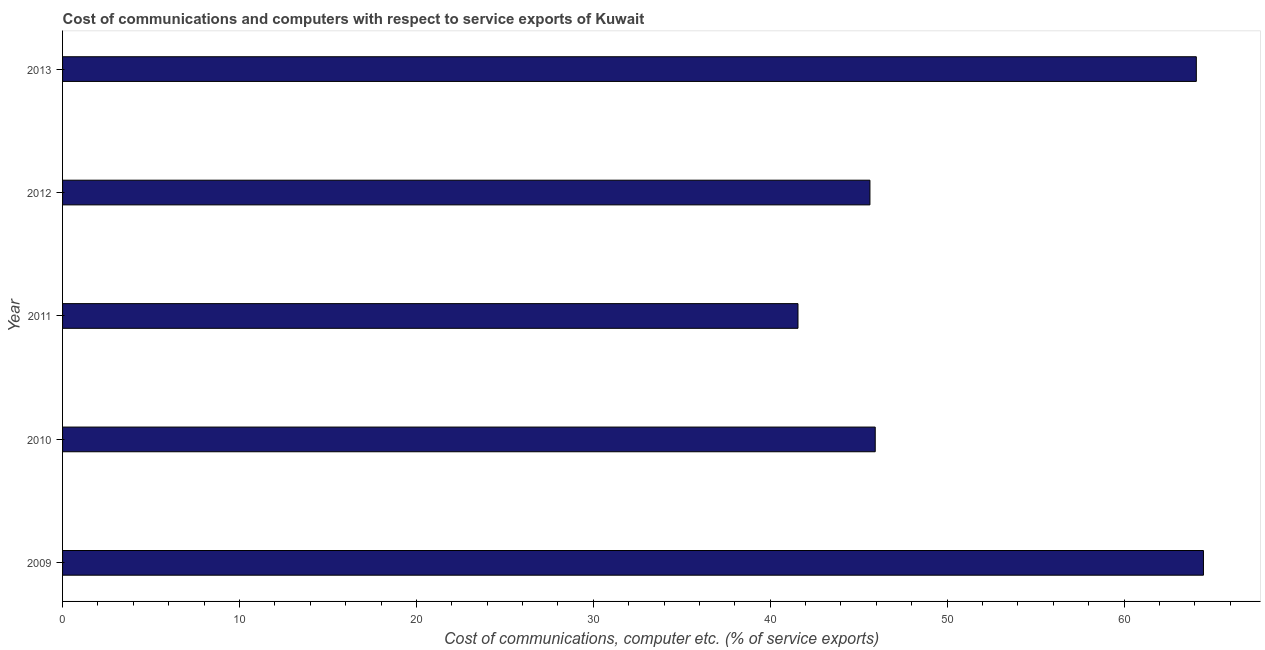What is the title of the graph?
Your answer should be very brief. Cost of communications and computers with respect to service exports of Kuwait. What is the label or title of the X-axis?
Make the answer very short. Cost of communications, computer etc. (% of service exports). What is the label or title of the Y-axis?
Make the answer very short. Year. What is the cost of communications and computer in 2013?
Make the answer very short. 64.09. Across all years, what is the maximum cost of communications and computer?
Keep it short and to the point. 64.49. Across all years, what is the minimum cost of communications and computer?
Offer a terse response. 41.57. In which year was the cost of communications and computer maximum?
Ensure brevity in your answer.  2009. What is the sum of the cost of communications and computer?
Offer a very short reply. 261.72. What is the difference between the cost of communications and computer in 2009 and 2012?
Give a very brief answer. 18.85. What is the average cost of communications and computer per year?
Your answer should be compact. 52.34. What is the median cost of communications and computer?
Provide a short and direct response. 45.94. In how many years, is the cost of communications and computer greater than 52 %?
Give a very brief answer. 2. What is the ratio of the cost of communications and computer in 2012 to that in 2013?
Give a very brief answer. 0.71. Is the cost of communications and computer in 2010 less than that in 2013?
Offer a very short reply. Yes. What is the difference between the highest and the second highest cost of communications and computer?
Your answer should be very brief. 0.4. What is the difference between the highest and the lowest cost of communications and computer?
Your answer should be very brief. 22.92. Are all the bars in the graph horizontal?
Give a very brief answer. Yes. Are the values on the major ticks of X-axis written in scientific E-notation?
Provide a succinct answer. No. What is the Cost of communications, computer etc. (% of service exports) in 2009?
Give a very brief answer. 64.49. What is the Cost of communications, computer etc. (% of service exports) of 2010?
Ensure brevity in your answer.  45.94. What is the Cost of communications, computer etc. (% of service exports) in 2011?
Make the answer very short. 41.57. What is the Cost of communications, computer etc. (% of service exports) of 2012?
Ensure brevity in your answer.  45.64. What is the Cost of communications, computer etc. (% of service exports) in 2013?
Keep it short and to the point. 64.09. What is the difference between the Cost of communications, computer etc. (% of service exports) in 2009 and 2010?
Ensure brevity in your answer.  18.55. What is the difference between the Cost of communications, computer etc. (% of service exports) in 2009 and 2011?
Ensure brevity in your answer.  22.92. What is the difference between the Cost of communications, computer etc. (% of service exports) in 2009 and 2012?
Offer a very short reply. 18.85. What is the difference between the Cost of communications, computer etc. (% of service exports) in 2009 and 2013?
Make the answer very short. 0.4. What is the difference between the Cost of communications, computer etc. (% of service exports) in 2010 and 2011?
Provide a succinct answer. 4.37. What is the difference between the Cost of communications, computer etc. (% of service exports) in 2010 and 2012?
Give a very brief answer. 0.3. What is the difference between the Cost of communications, computer etc. (% of service exports) in 2010 and 2013?
Your answer should be very brief. -18.15. What is the difference between the Cost of communications, computer etc. (% of service exports) in 2011 and 2012?
Ensure brevity in your answer.  -4.07. What is the difference between the Cost of communications, computer etc. (% of service exports) in 2011 and 2013?
Your answer should be compact. -22.52. What is the difference between the Cost of communications, computer etc. (% of service exports) in 2012 and 2013?
Your response must be concise. -18.45. What is the ratio of the Cost of communications, computer etc. (% of service exports) in 2009 to that in 2010?
Keep it short and to the point. 1.4. What is the ratio of the Cost of communications, computer etc. (% of service exports) in 2009 to that in 2011?
Your response must be concise. 1.55. What is the ratio of the Cost of communications, computer etc. (% of service exports) in 2009 to that in 2012?
Offer a terse response. 1.41. What is the ratio of the Cost of communications, computer etc. (% of service exports) in 2009 to that in 2013?
Give a very brief answer. 1.01. What is the ratio of the Cost of communications, computer etc. (% of service exports) in 2010 to that in 2011?
Offer a very short reply. 1.1. What is the ratio of the Cost of communications, computer etc. (% of service exports) in 2010 to that in 2012?
Offer a terse response. 1.01. What is the ratio of the Cost of communications, computer etc. (% of service exports) in 2010 to that in 2013?
Make the answer very short. 0.72. What is the ratio of the Cost of communications, computer etc. (% of service exports) in 2011 to that in 2012?
Provide a succinct answer. 0.91. What is the ratio of the Cost of communications, computer etc. (% of service exports) in 2011 to that in 2013?
Offer a terse response. 0.65. What is the ratio of the Cost of communications, computer etc. (% of service exports) in 2012 to that in 2013?
Ensure brevity in your answer.  0.71. 